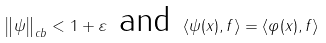<formula> <loc_0><loc_0><loc_500><loc_500>\left \| \psi \right \| _ { c b } < 1 + \varepsilon \text { and } \langle \psi ( x ) , f \rangle = \langle \varphi ( x ) , f \rangle</formula> 